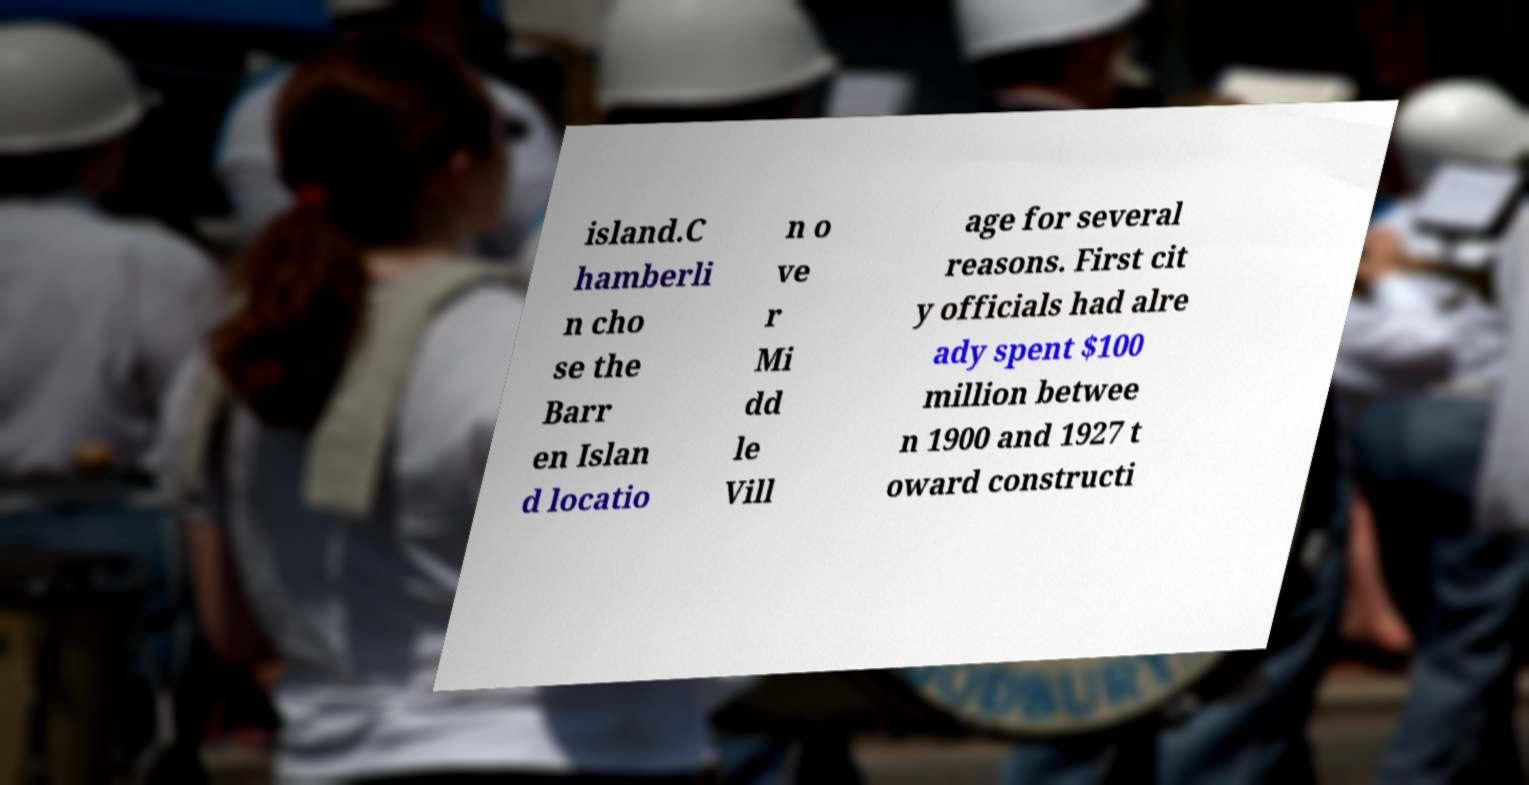Can you read and provide the text displayed in the image?This photo seems to have some interesting text. Can you extract and type it out for me? island.C hamberli n cho se the Barr en Islan d locatio n o ve r Mi dd le Vill age for several reasons. First cit y officials had alre ady spent $100 million betwee n 1900 and 1927 t oward constructi 